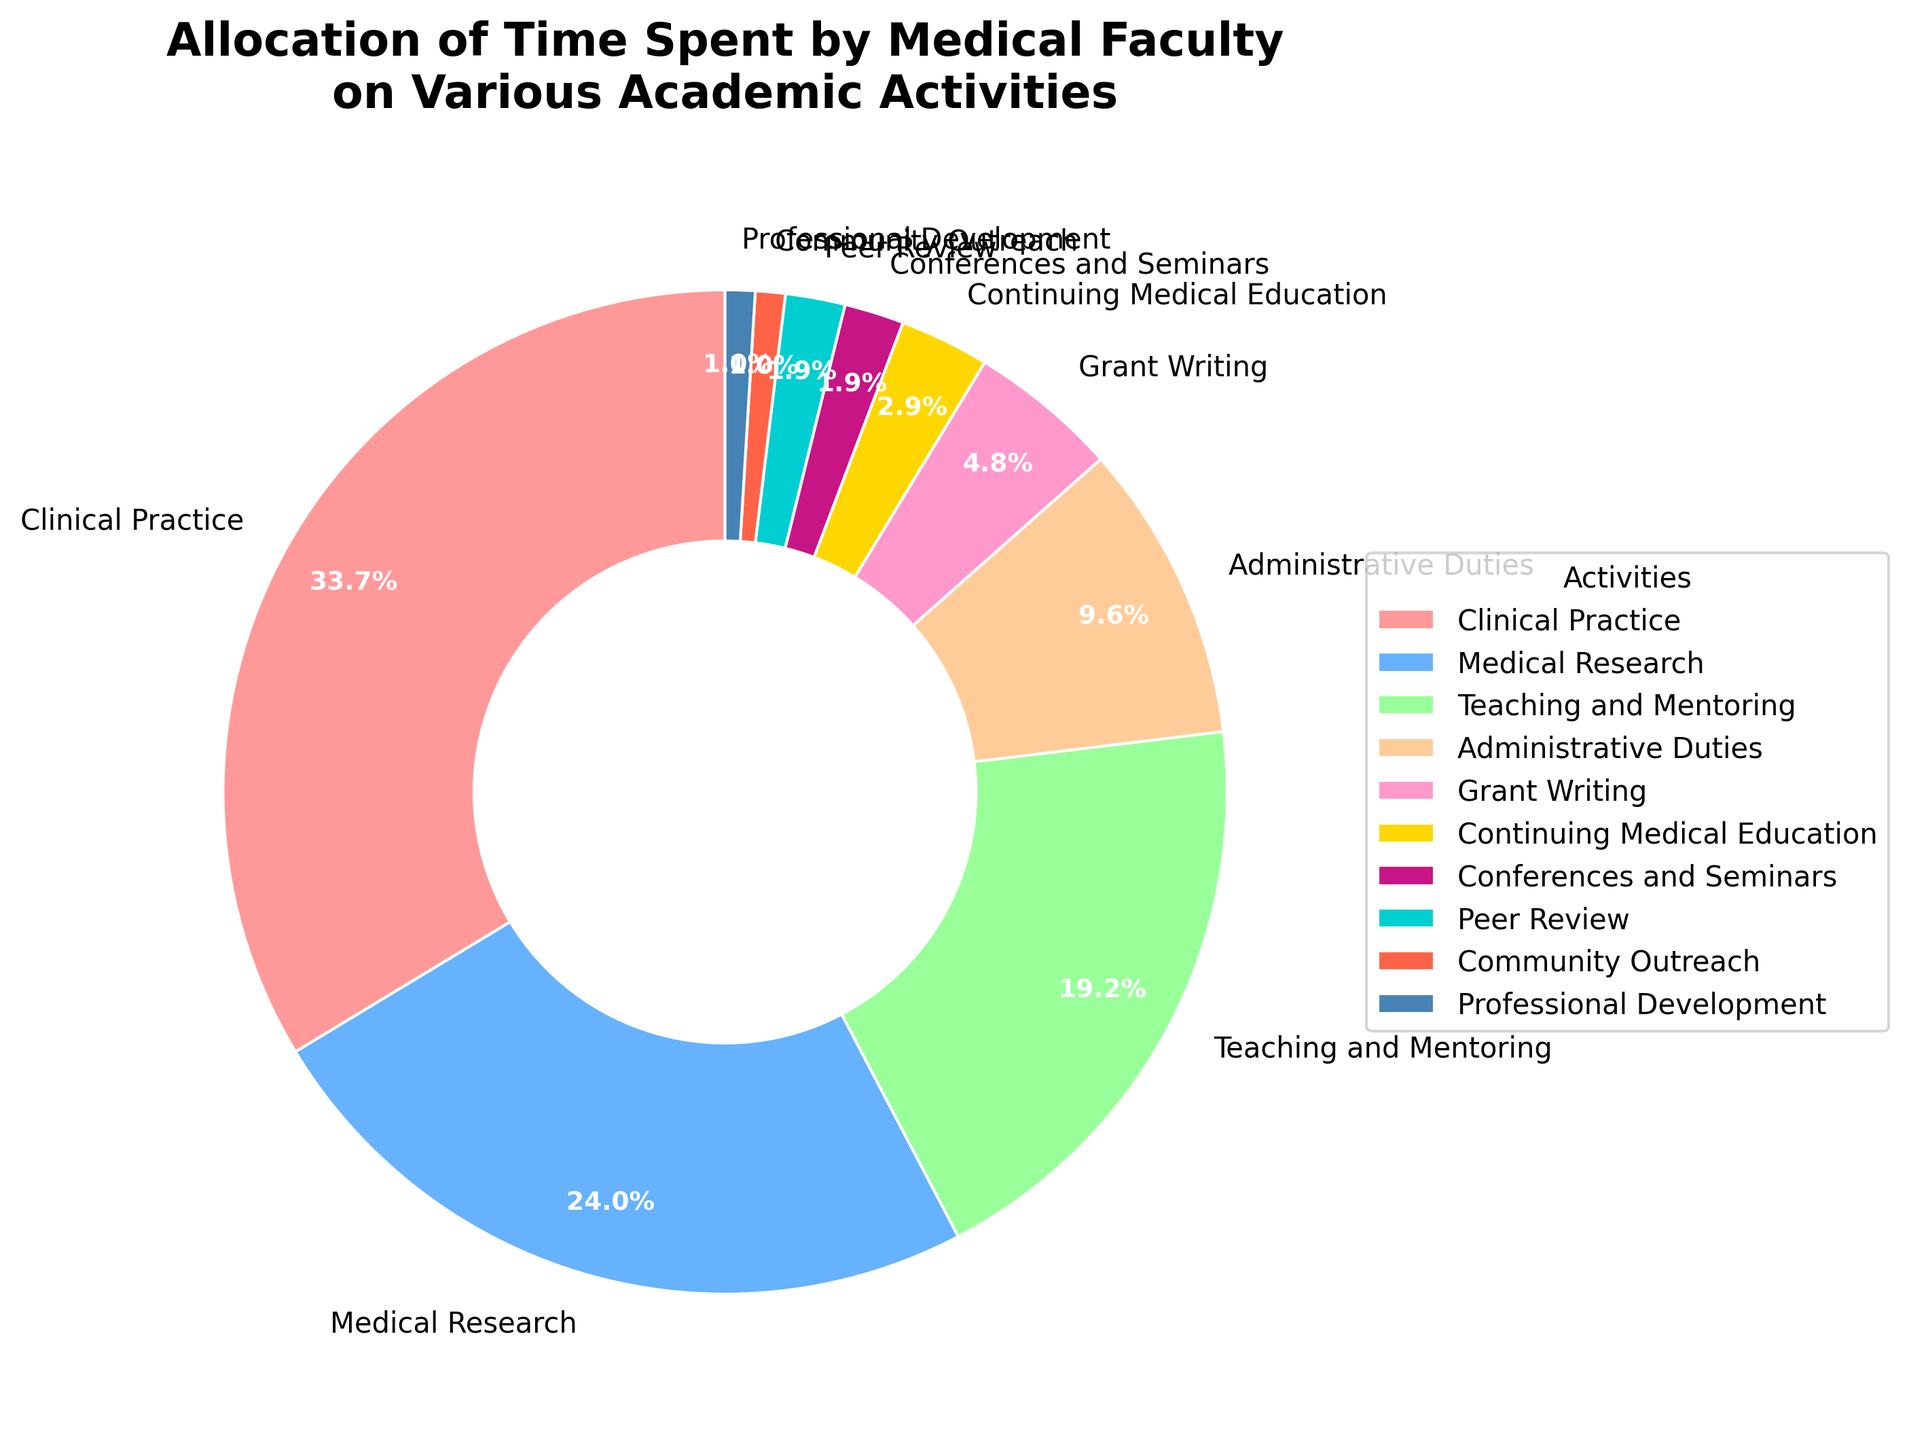Which activity takes the largest portion of the medical faculty's time? Clinical Practice takes the largest portion, as indicated by its slice being the largest.
Answer: Clinical Practice How much time do clinical practice and medical research occupy combined? The percentage for Clinical Practice is 35%, and for Medical Research, it is 25%. Adding these together, 35% + 25% = 60%.
Answer: 60% Which activities each take up less than 5% of the medical faculty's time? The activities with segments labeled less than 5% are Grant Writing (5%), Continuing Medical Education (3%), Conferences and Seminars (2%), Peer Review (2%), Community Outreach (1%), and Professional Development (1%).
Answer: Continuing Medical Education, Conferences and Seminars, Peer Review, Community Outreach, Professional Development Is more time allocated to administrative duties or teaching and mentoring? The slice for Teaching and Mentoring is larger at 20%, while Administrative Duties take up 10%. Thus, more time is allocated to Teaching and Mentoring.
Answer: Teaching and Mentoring What is the total percentage of time spent on activities related to professional growth (Continuing Medical Education, Conferences and Seminars, Professional Development)? Continuing Medical Education is 3%, Conferences and Seminars is 2%, and Professional Development is 1%. Adding them together, 3% + 2% + 1% = 6%.
Answer: 6% How does the time spent on peer review compare to community outreach? Both Peer Review and Community Outreach each take up 2% and 1% respectively. The percentage for Peer Review (2%) is greater than for Community Outreach (1%).
Answer: Peer Review What are the colors of the slices representing clinical practice and medical research? The slice for Clinical Practice is a shade of red, and the slice for Medical Research is blue.
Answer: Red and Blue 